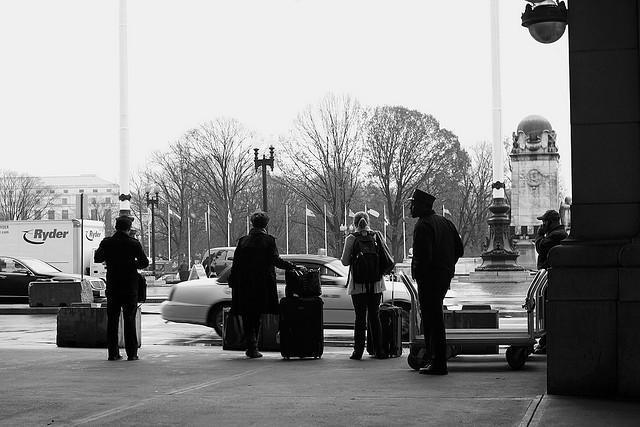What building did the people come from?
Select the accurate answer and provide justification: `Answer: choice
Rationale: srationale.`
Options: Hotel, train station, ferry terminal, airport. Answer: airport.
Rationale: They are seen with suitcase in their hands. 